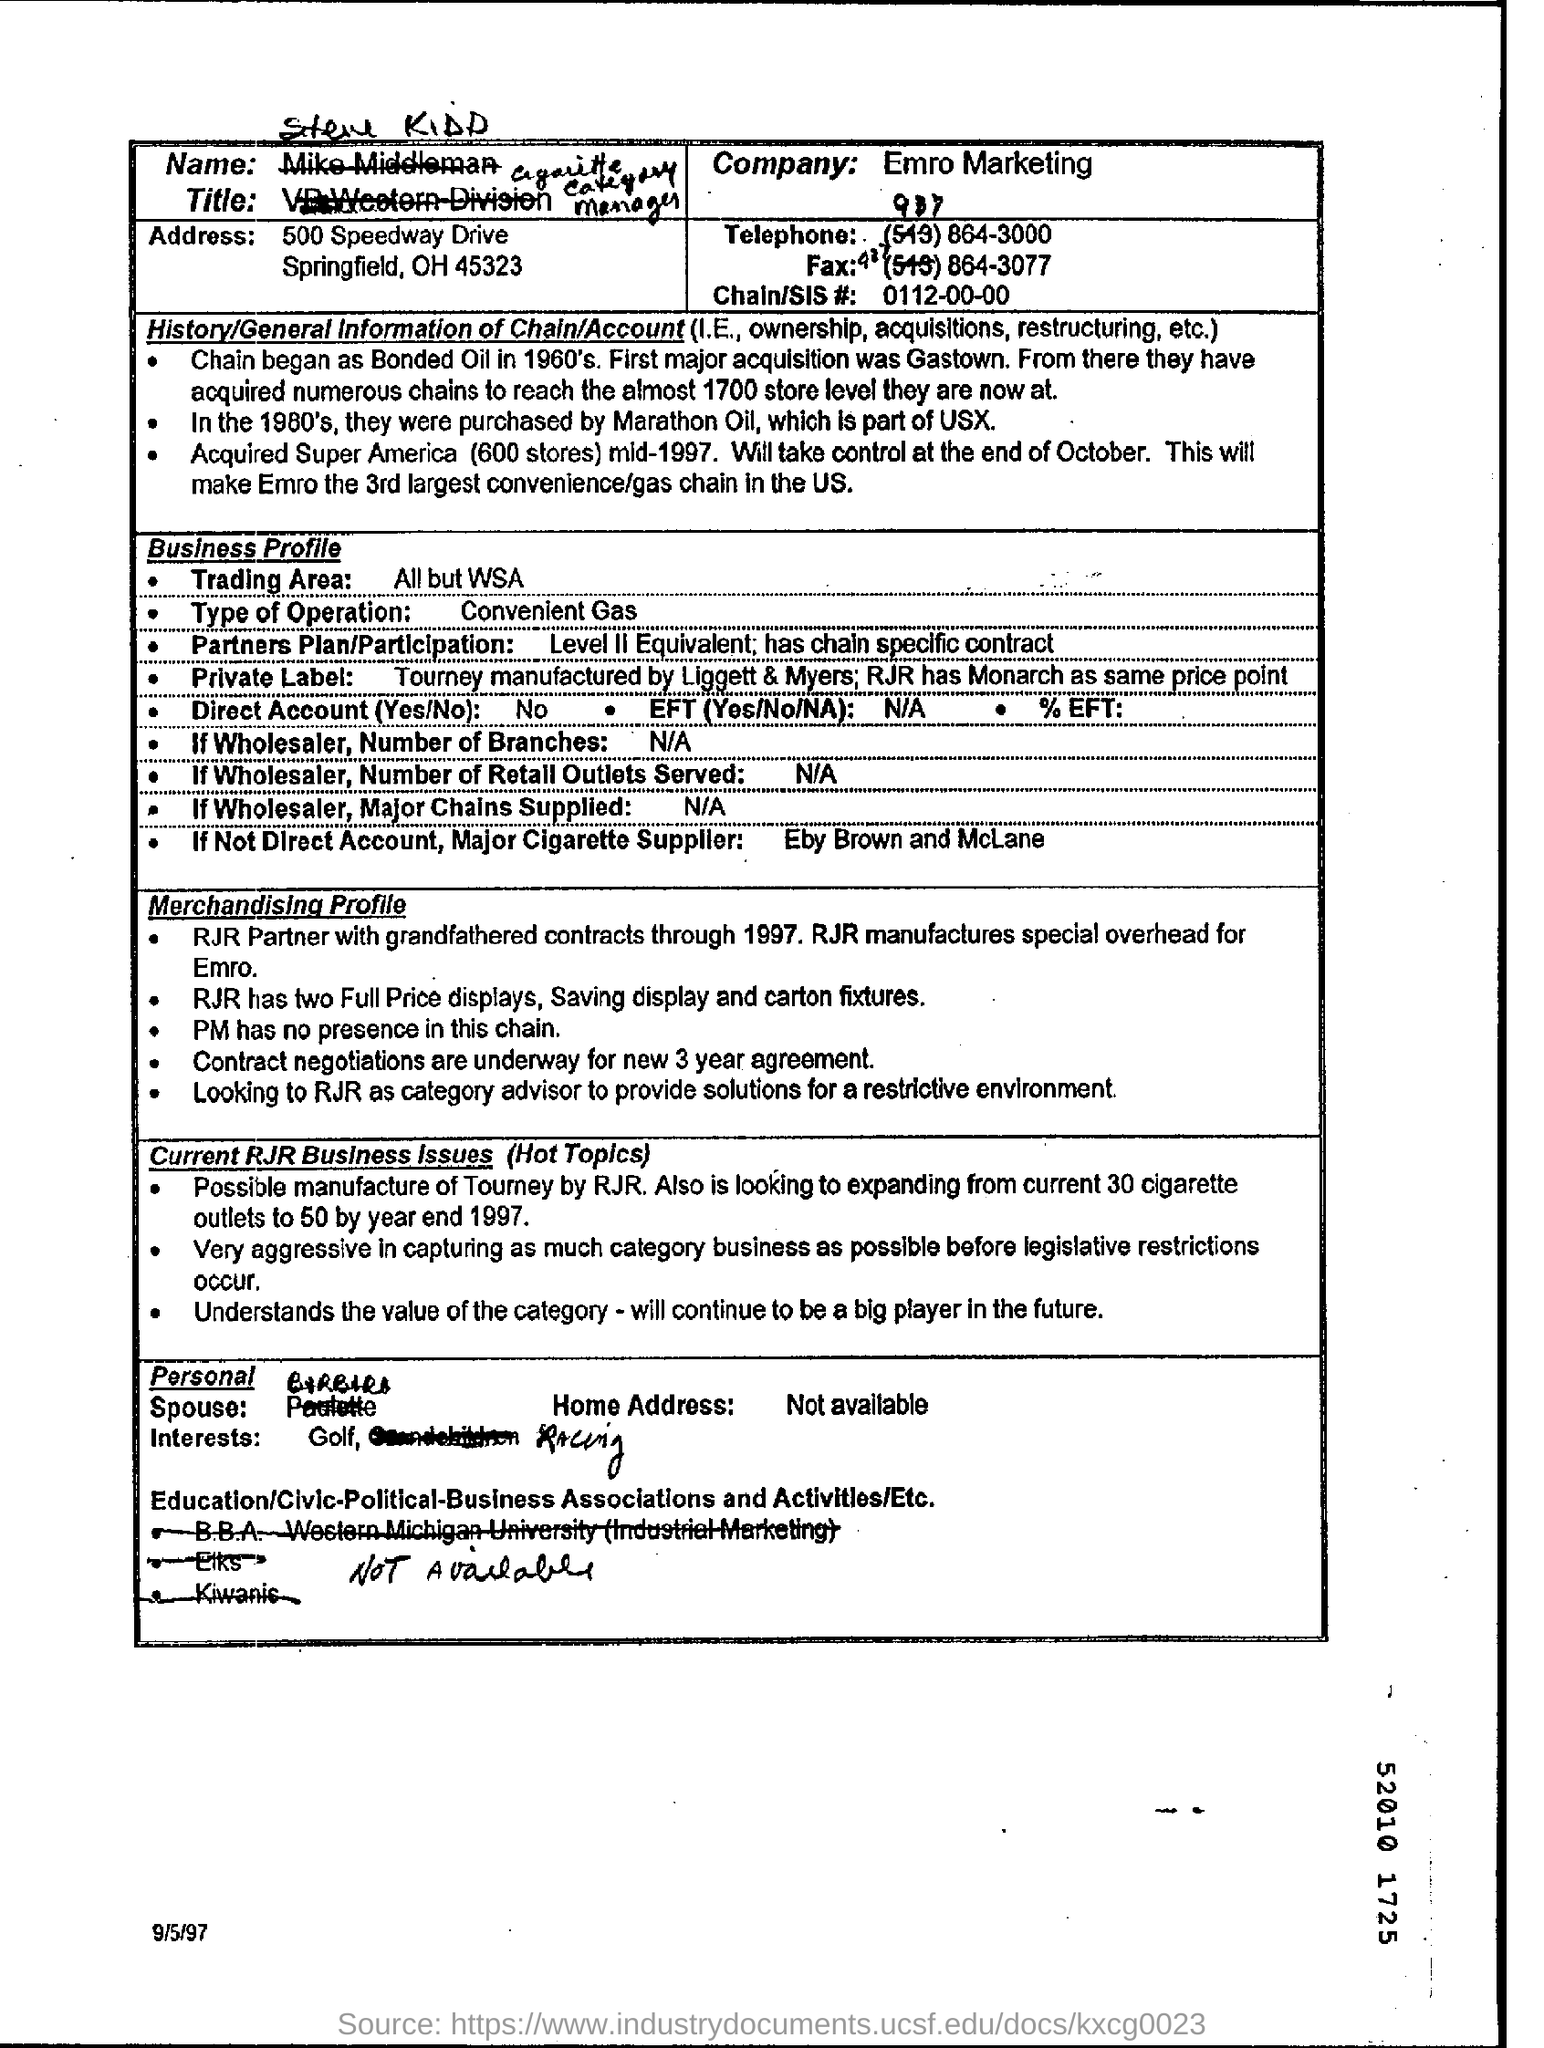Specify some key components in this picture. The type of operation is convenient gas. The trading area includes all locations except for WSA. 